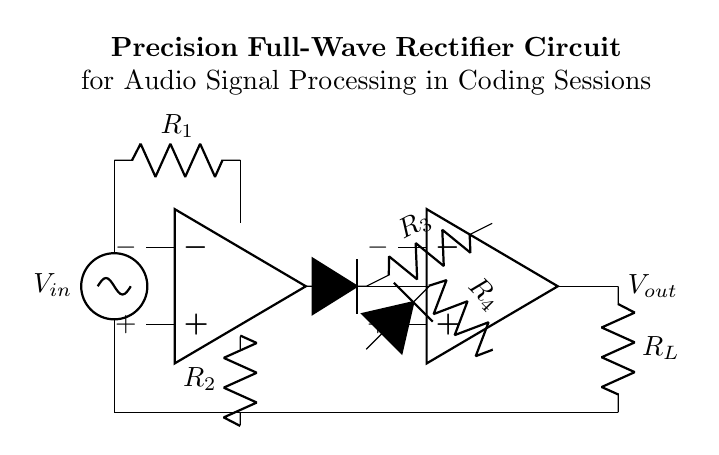What is the input voltage of the circuit? The input voltage is labeled as V_in; it represents the voltage applied to the circuit.
Answer: V_in How many operational amplifiers are present in the circuit? The circuit diagram shows two blocks labeled as operational amplifiers (op amps); thus, there are two op amps in the circuit.
Answer: 2 What is the function of the diodes in this circuit? The diodes are used to allow current to flow in one direction and block it in the opposite direction, which is essential for rectification.
Answer: Rectification What is the purpose of the resistor R_1? R_1 is connected in series with the input voltage and is likely used for setting the gain or limiting the current through the operational amplifier; it shapes signal characteristics.
Answer: Set gain Which component connects to the load resistor R_L? The output voltage V_out connects to the load resistor R_L; this indicates where the processed signal is outputted to an external load.
Answer: V_out What type of rectifier does this circuit configuration represent? This configuration is a full-wave rectifier since it utilizes two operational amplifiers and diodes to produce a rectified output for both halves of the input waveform.
Answer: Full-wave rectifier 